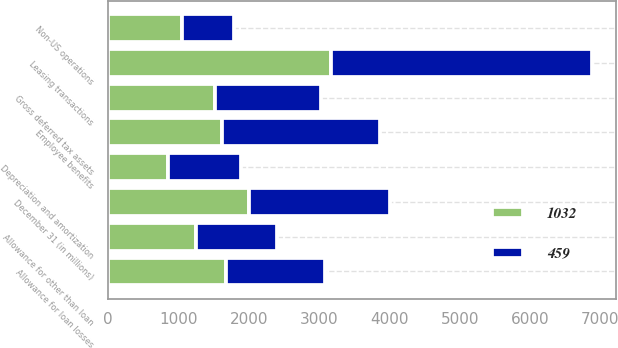<chart> <loc_0><loc_0><loc_500><loc_500><stacked_bar_chart><ecel><fcel>December 31 (in millions)<fcel>Employee benefits<fcel>Allowance for loan losses<fcel>Allowance for other than loan<fcel>Non-US operations<fcel>Gross deferred tax assets<fcel>Leasing transactions<fcel>Depreciation and amortization<nl><fcel>459<fcel>2003<fcel>2245<fcel>1410<fcel>1152<fcel>741<fcel>1515.5<fcel>3703<fcel>1037<nl><fcel>1032<fcel>2002<fcel>1621<fcel>1675<fcel>1251<fcel>1055<fcel>1515.5<fcel>3175<fcel>857<nl></chart> 